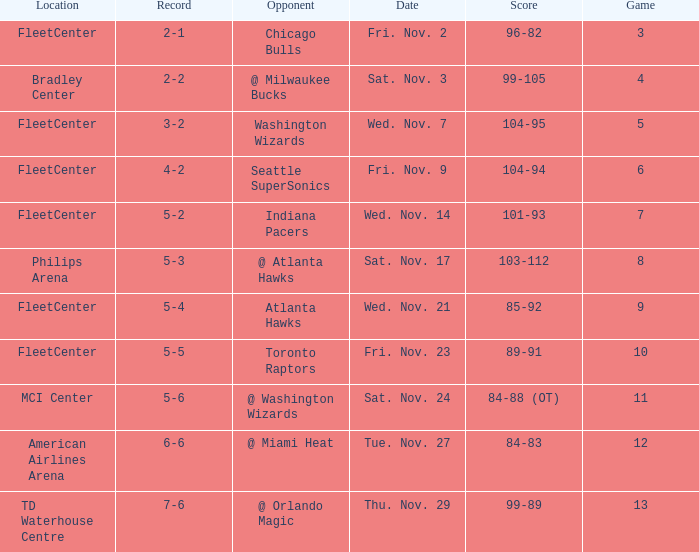On what date did Fleetcenter have a game lower than 9 with a score of 104-94? Fri. Nov. 9. 